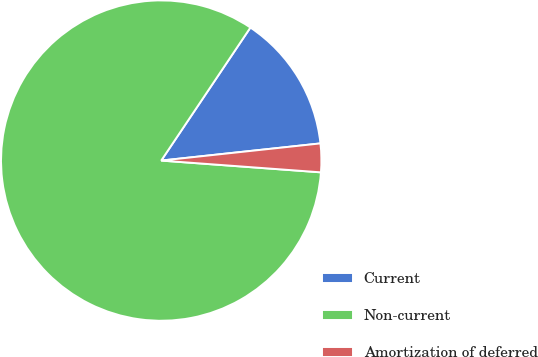Convert chart. <chart><loc_0><loc_0><loc_500><loc_500><pie_chart><fcel>Current<fcel>Non-current<fcel>Amortization of deferred<nl><fcel>13.89%<fcel>83.23%<fcel>2.88%<nl></chart> 